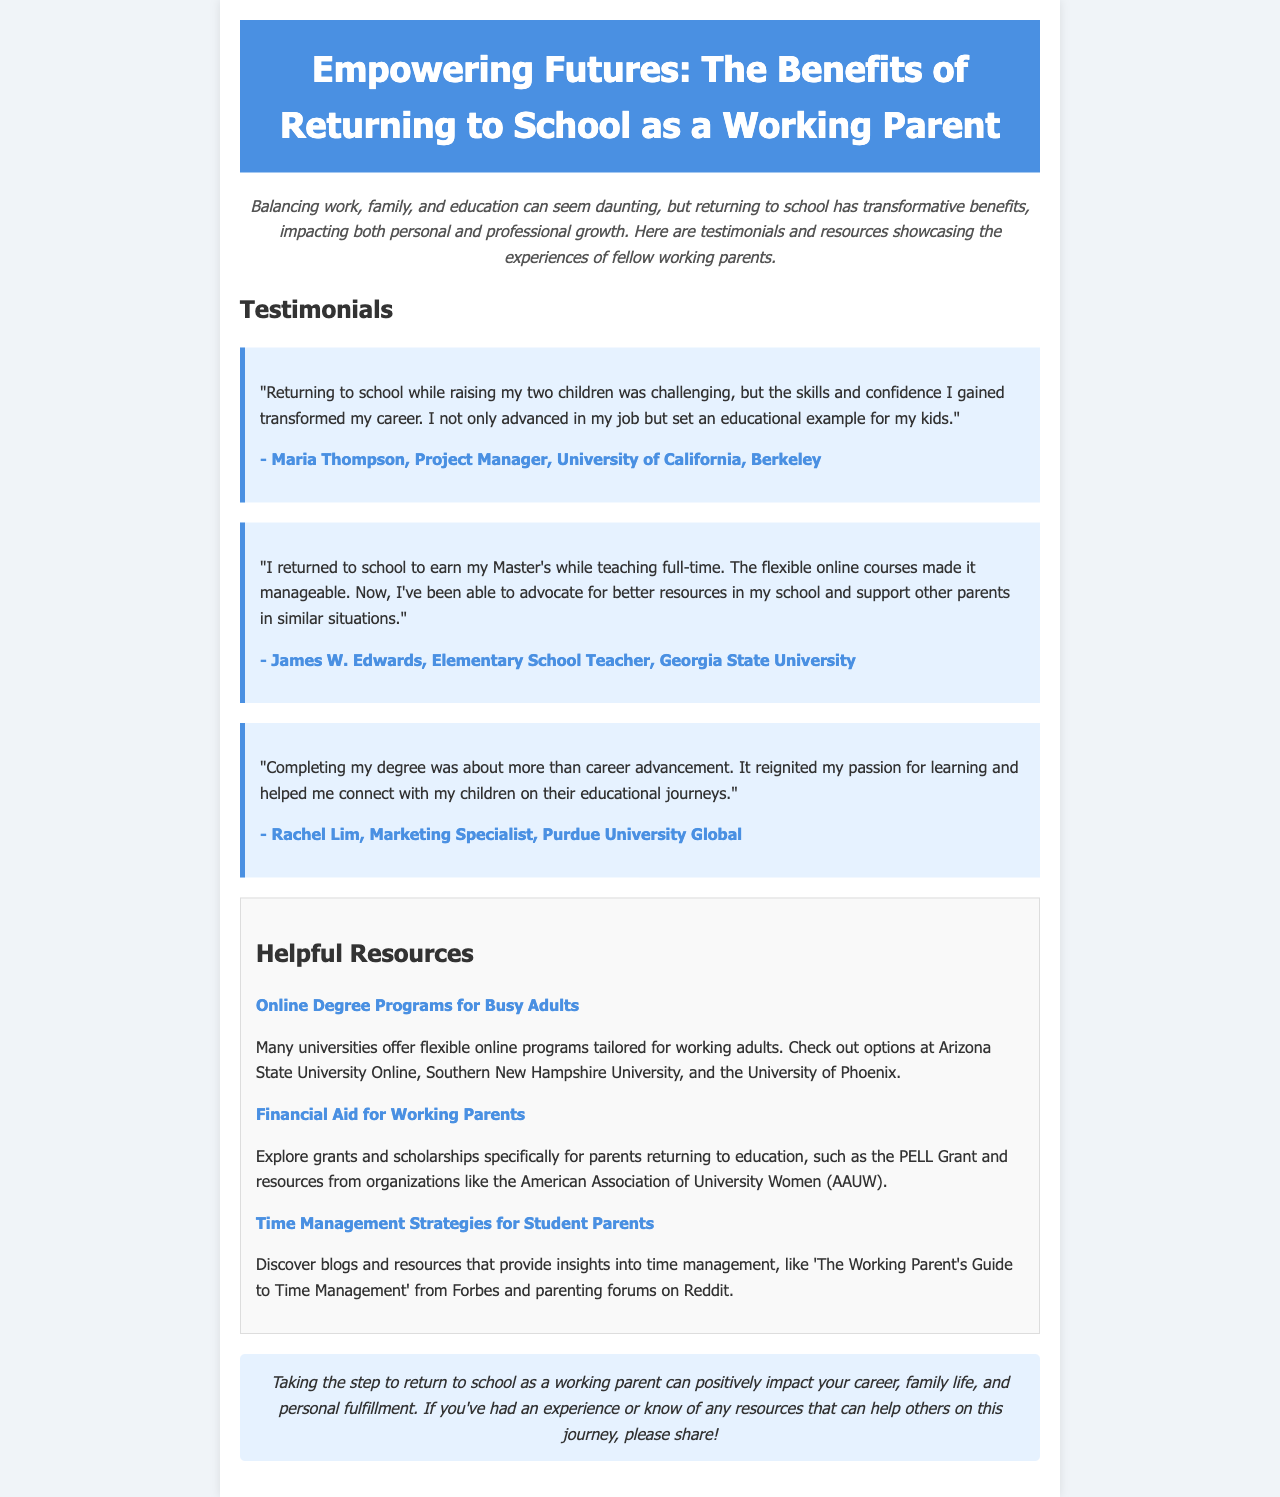What is the title of the newsletter? The title is stated at the top of the document, reflecting the content focus.
Answer: Empowering Futures: The Benefits of Returning to School as a Working Parent Who wrote the testimonial about teaching full-time? The document gives the name of the person who shared their experience related to teaching and returning to school.
Answer: James W. Edwards What university did Maria Thompson attend? The document specifies the university attended by Maria Thompson, providing direct information.
Answer: University of California, Berkeley How many testimonials are featured in the document? By counting the provided testimonials, we determine the total number included.
Answer: Three What is one online university mentioned for flexible programs? The document lists specific universities offering online degree programs for busy adults.
Answer: Arizona State University Online What type of aid is available for working parents according to the resources? The document mentions specific financial aid options available to support working parents returning to education.
Answer: Grants and scholarships What personal benefit did Rachel Lim mention about completing her degree? The document highlights Rachel Lim's reflection on a personal improvement related to her education journey.
Answer: Reignited passion for learning What is the style of the concluding remarks in the newsletter? The conclusion section has a specific tone or format that reflects on the overall message of the document.
Answer: Italic 